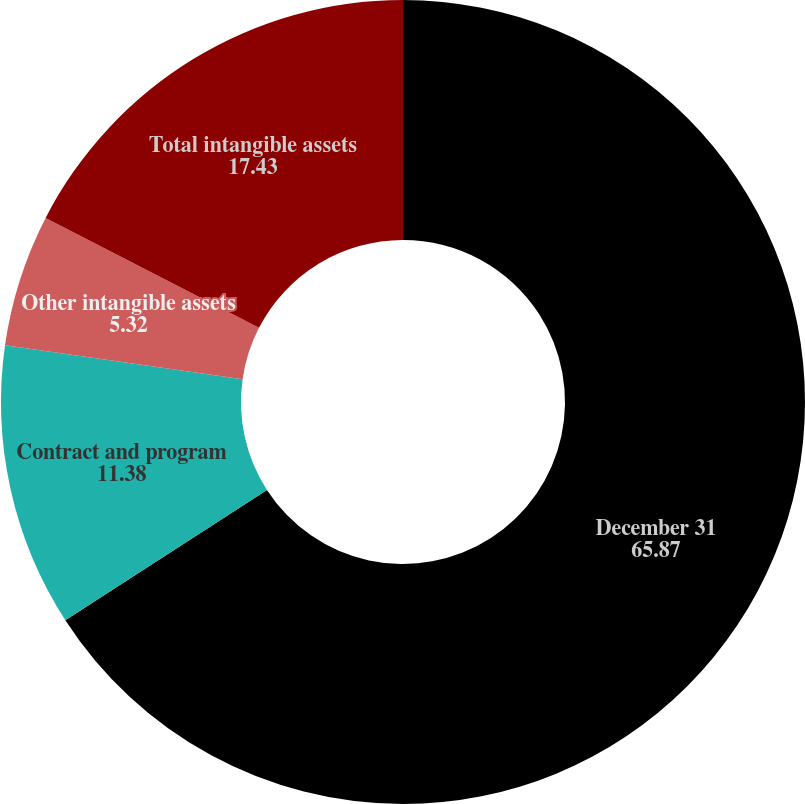Convert chart. <chart><loc_0><loc_0><loc_500><loc_500><pie_chart><fcel>December 31<fcel>Contract and program<fcel>Other intangible assets<fcel>Total intangible assets<nl><fcel>65.87%<fcel>11.38%<fcel>5.32%<fcel>17.43%<nl></chart> 